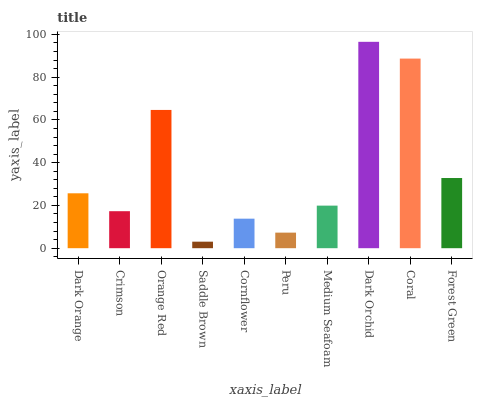Is Saddle Brown the minimum?
Answer yes or no. Yes. Is Dark Orchid the maximum?
Answer yes or no. Yes. Is Crimson the minimum?
Answer yes or no. No. Is Crimson the maximum?
Answer yes or no. No. Is Dark Orange greater than Crimson?
Answer yes or no. Yes. Is Crimson less than Dark Orange?
Answer yes or no. Yes. Is Crimson greater than Dark Orange?
Answer yes or no. No. Is Dark Orange less than Crimson?
Answer yes or no. No. Is Dark Orange the high median?
Answer yes or no. Yes. Is Medium Seafoam the low median?
Answer yes or no. Yes. Is Orange Red the high median?
Answer yes or no. No. Is Coral the low median?
Answer yes or no. No. 